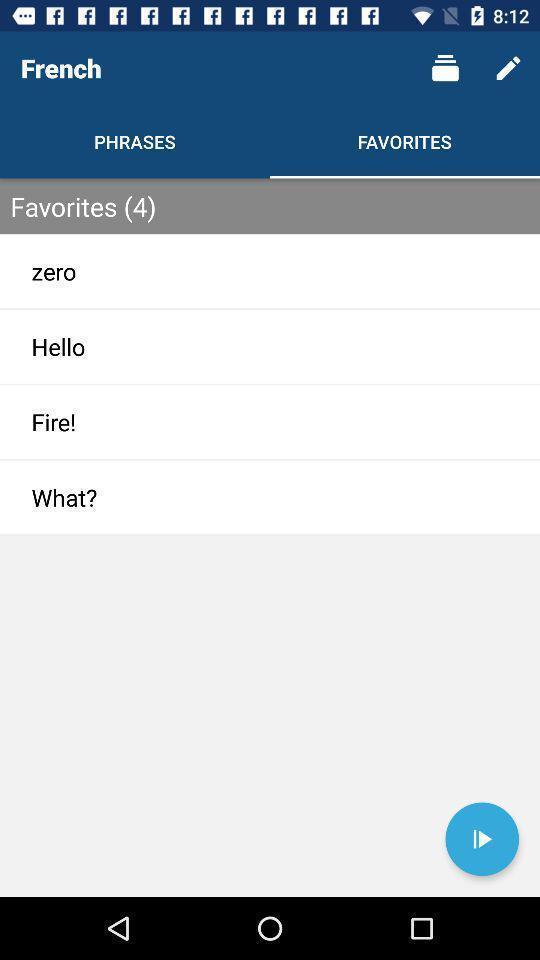Please provide a description for this image. Page showing the favorites. 